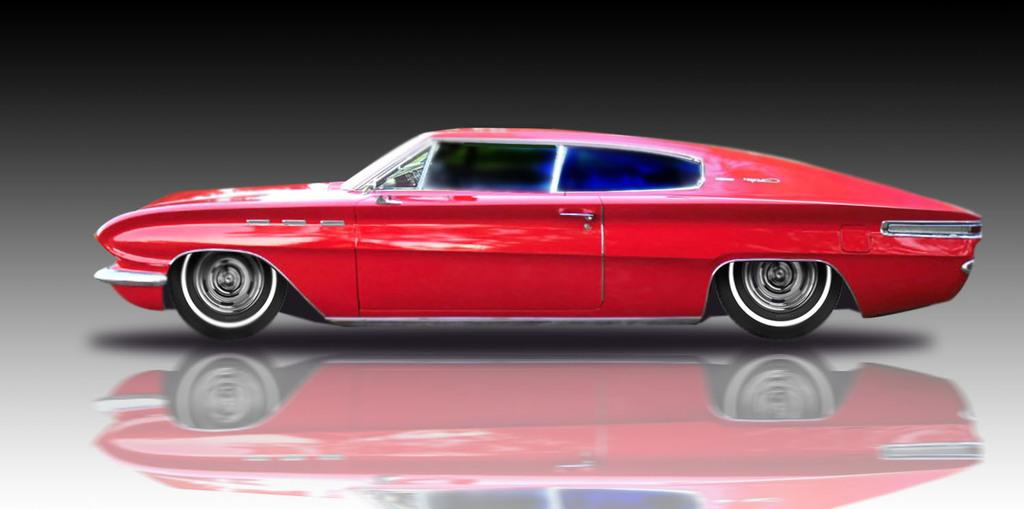What is the main subject of the image? There is a car in the image. What color is the car? The car is red. What is the surface beneath the car? The car is placed on a white surface. What color is the background of the image? The background of the image is black. What type of watch is the car wearing in the image? There is no watch present in the image, as cars do not wear watches. 